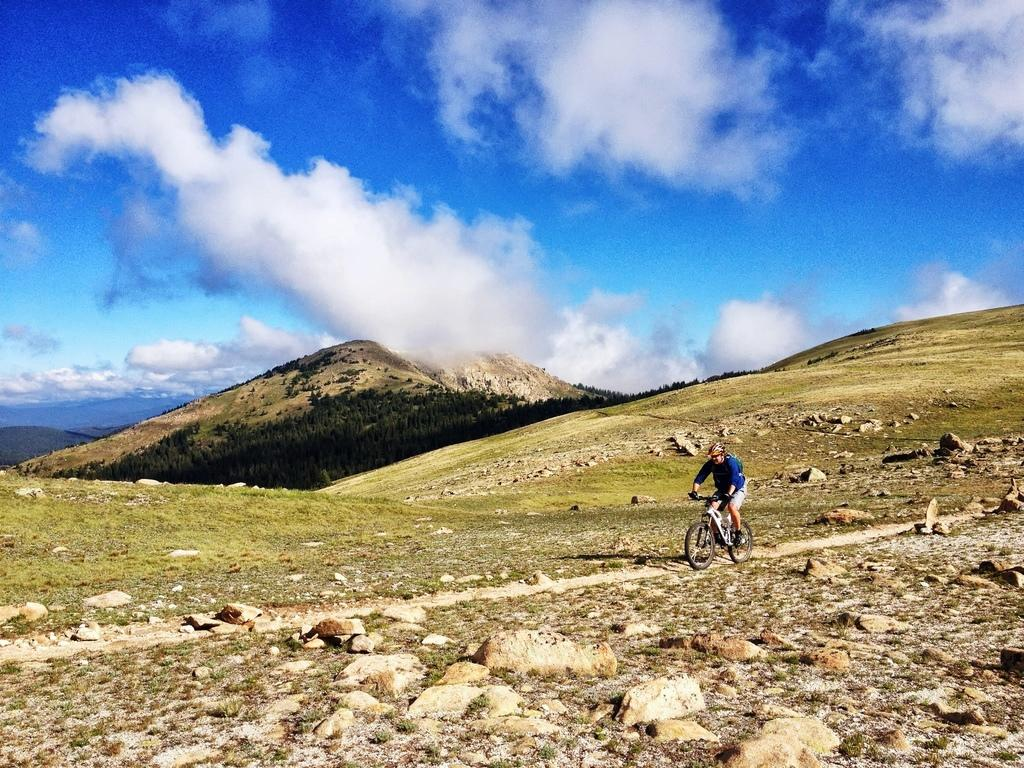What is the person in the image doing? The person is riding a bicycle in the image. What is the person wearing while riding the bicycle? The person is wearing a helmet in the image. What can be seen in the background of the image? There are hills and trees visible in the image. What is the condition of the sky in the image? The sky has clouds in the image. What type of comb is the person using to style their hair in the image? There is no comb visible in the image, as the person is wearing a helmet. What hobbies does the person have, as seen in the image? The image only shows the person riding a bicycle, so we cannot determine any other hobbies they might have. 